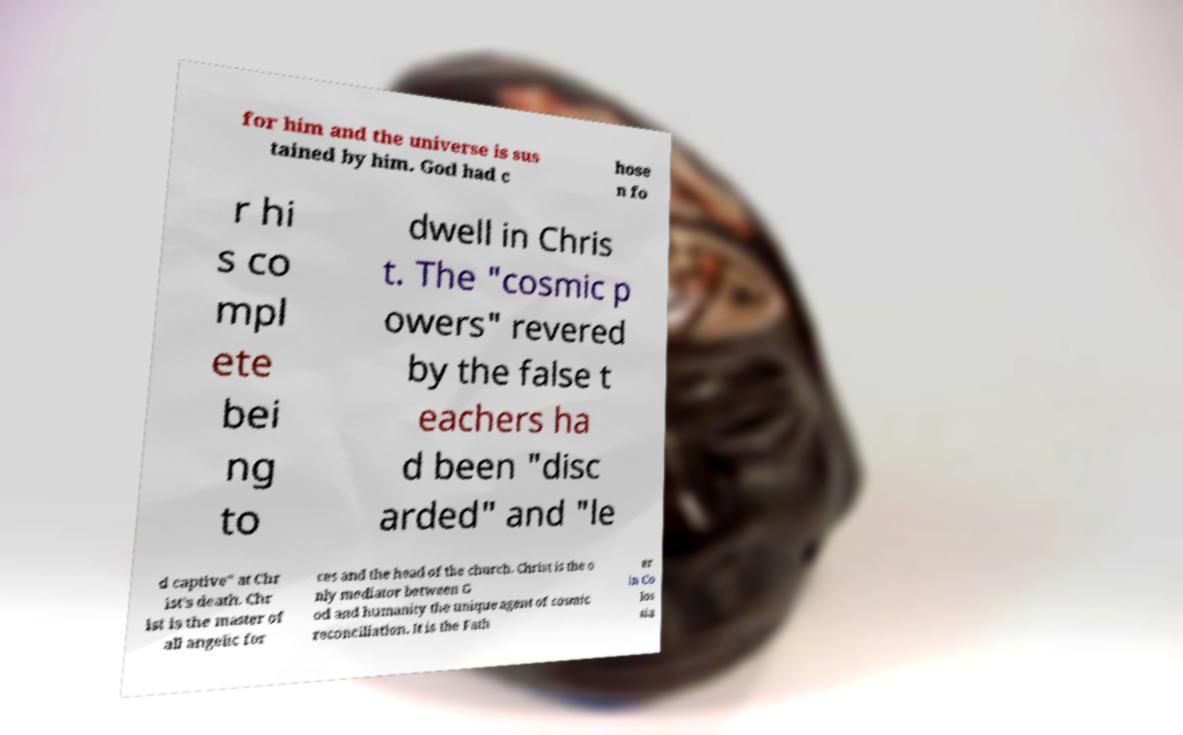Can you accurately transcribe the text from the provided image for me? for him and the universe is sus tained by him. God had c hose n fo r hi s co mpl ete bei ng to dwell in Chris t. The "cosmic p owers" revered by the false t eachers ha d been "disc arded" and "le d captive" at Chr ist's death. Chr ist is the master of all angelic for ces and the head of the church. Christ is the o nly mediator between G od and humanity the unique agent of cosmic reconciliation. It is the Fath er in Co los sia 